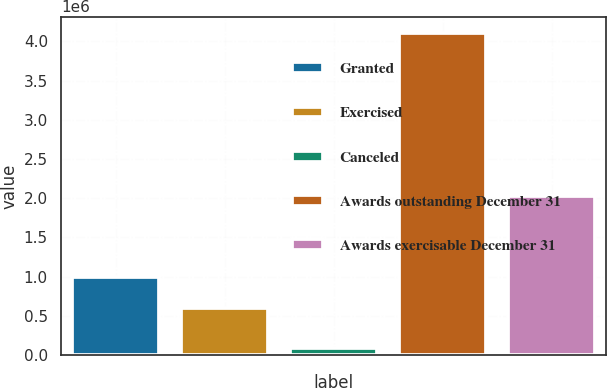Convert chart. <chart><loc_0><loc_0><loc_500><loc_500><bar_chart><fcel>Granted<fcel>Exercised<fcel>Canceled<fcel>Awards outstanding December 31<fcel>Awards exercisable December 31<nl><fcel>998891<fcel>597300<fcel>94532<fcel>4.11044e+06<fcel>2.02306e+06<nl></chart> 